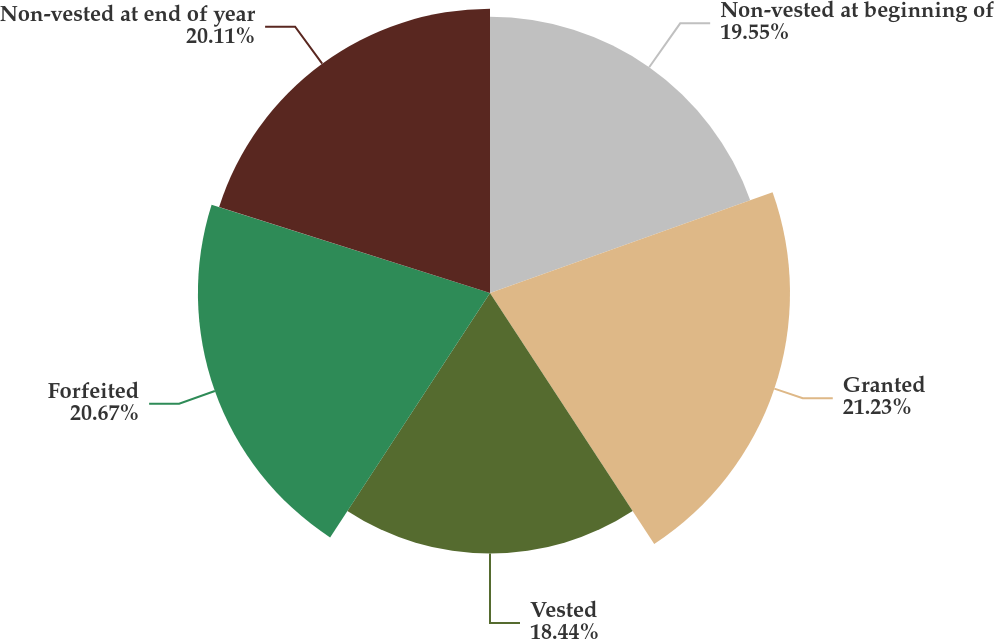<chart> <loc_0><loc_0><loc_500><loc_500><pie_chart><fcel>Non-vested at beginning of<fcel>Granted<fcel>Vested<fcel>Forfeited<fcel>Non-vested at end of year<nl><fcel>19.55%<fcel>21.23%<fcel>18.44%<fcel>20.67%<fcel>20.11%<nl></chart> 